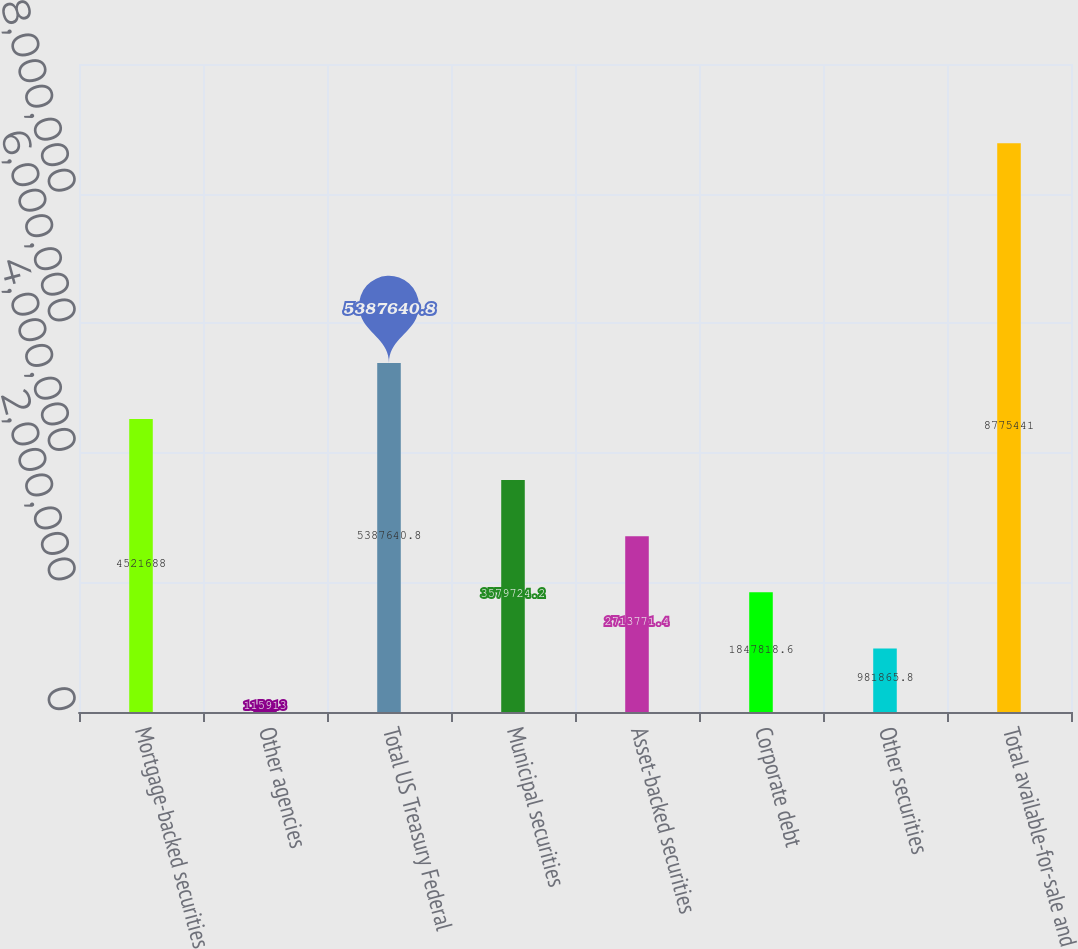Convert chart. <chart><loc_0><loc_0><loc_500><loc_500><bar_chart><fcel>Mortgage-backed securities<fcel>Other agencies<fcel>Total US Treasury Federal<fcel>Municipal securities<fcel>Asset-backed securities<fcel>Corporate debt<fcel>Other securities<fcel>Total available-for-sale and<nl><fcel>4.52169e+06<fcel>115913<fcel>5.38764e+06<fcel>3.57972e+06<fcel>2.71377e+06<fcel>1.84782e+06<fcel>981866<fcel>8.77544e+06<nl></chart> 